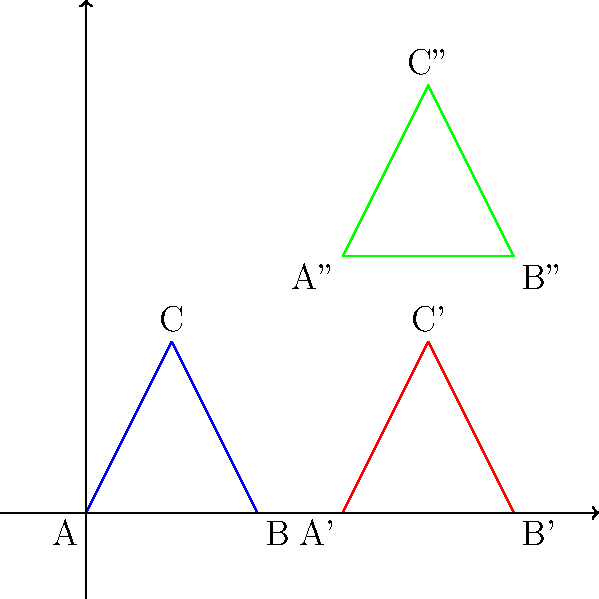In the given figure, triangle ABC undergoes two transformations to reach its final position as triangle A''B''C''. Identify the sequence of transformations applied to triangle ABC to reach its final position. Let's analyze the transformations step by step:

1. From triangle ABC to triangle A'B'C':
   - The triangle moves 3 units to the right.
   - This is a translation by the vector (3, 0).

2. From triangle A'B'C' to triangle A''B''C'':
   - The triangle moves 3 units up.
   - This is a translation by the vector (0, 3).

Therefore, the sequence of transformations is:
1. Translation by vector (3, 0)
2. Translation by vector (0, 3)

We can combine these two translations into a single translation by vector (3, 3), but the question asks for the sequence, so we'll keep them separate in our answer.
Answer: Translation by (3, 0) followed by translation by (0, 3) 